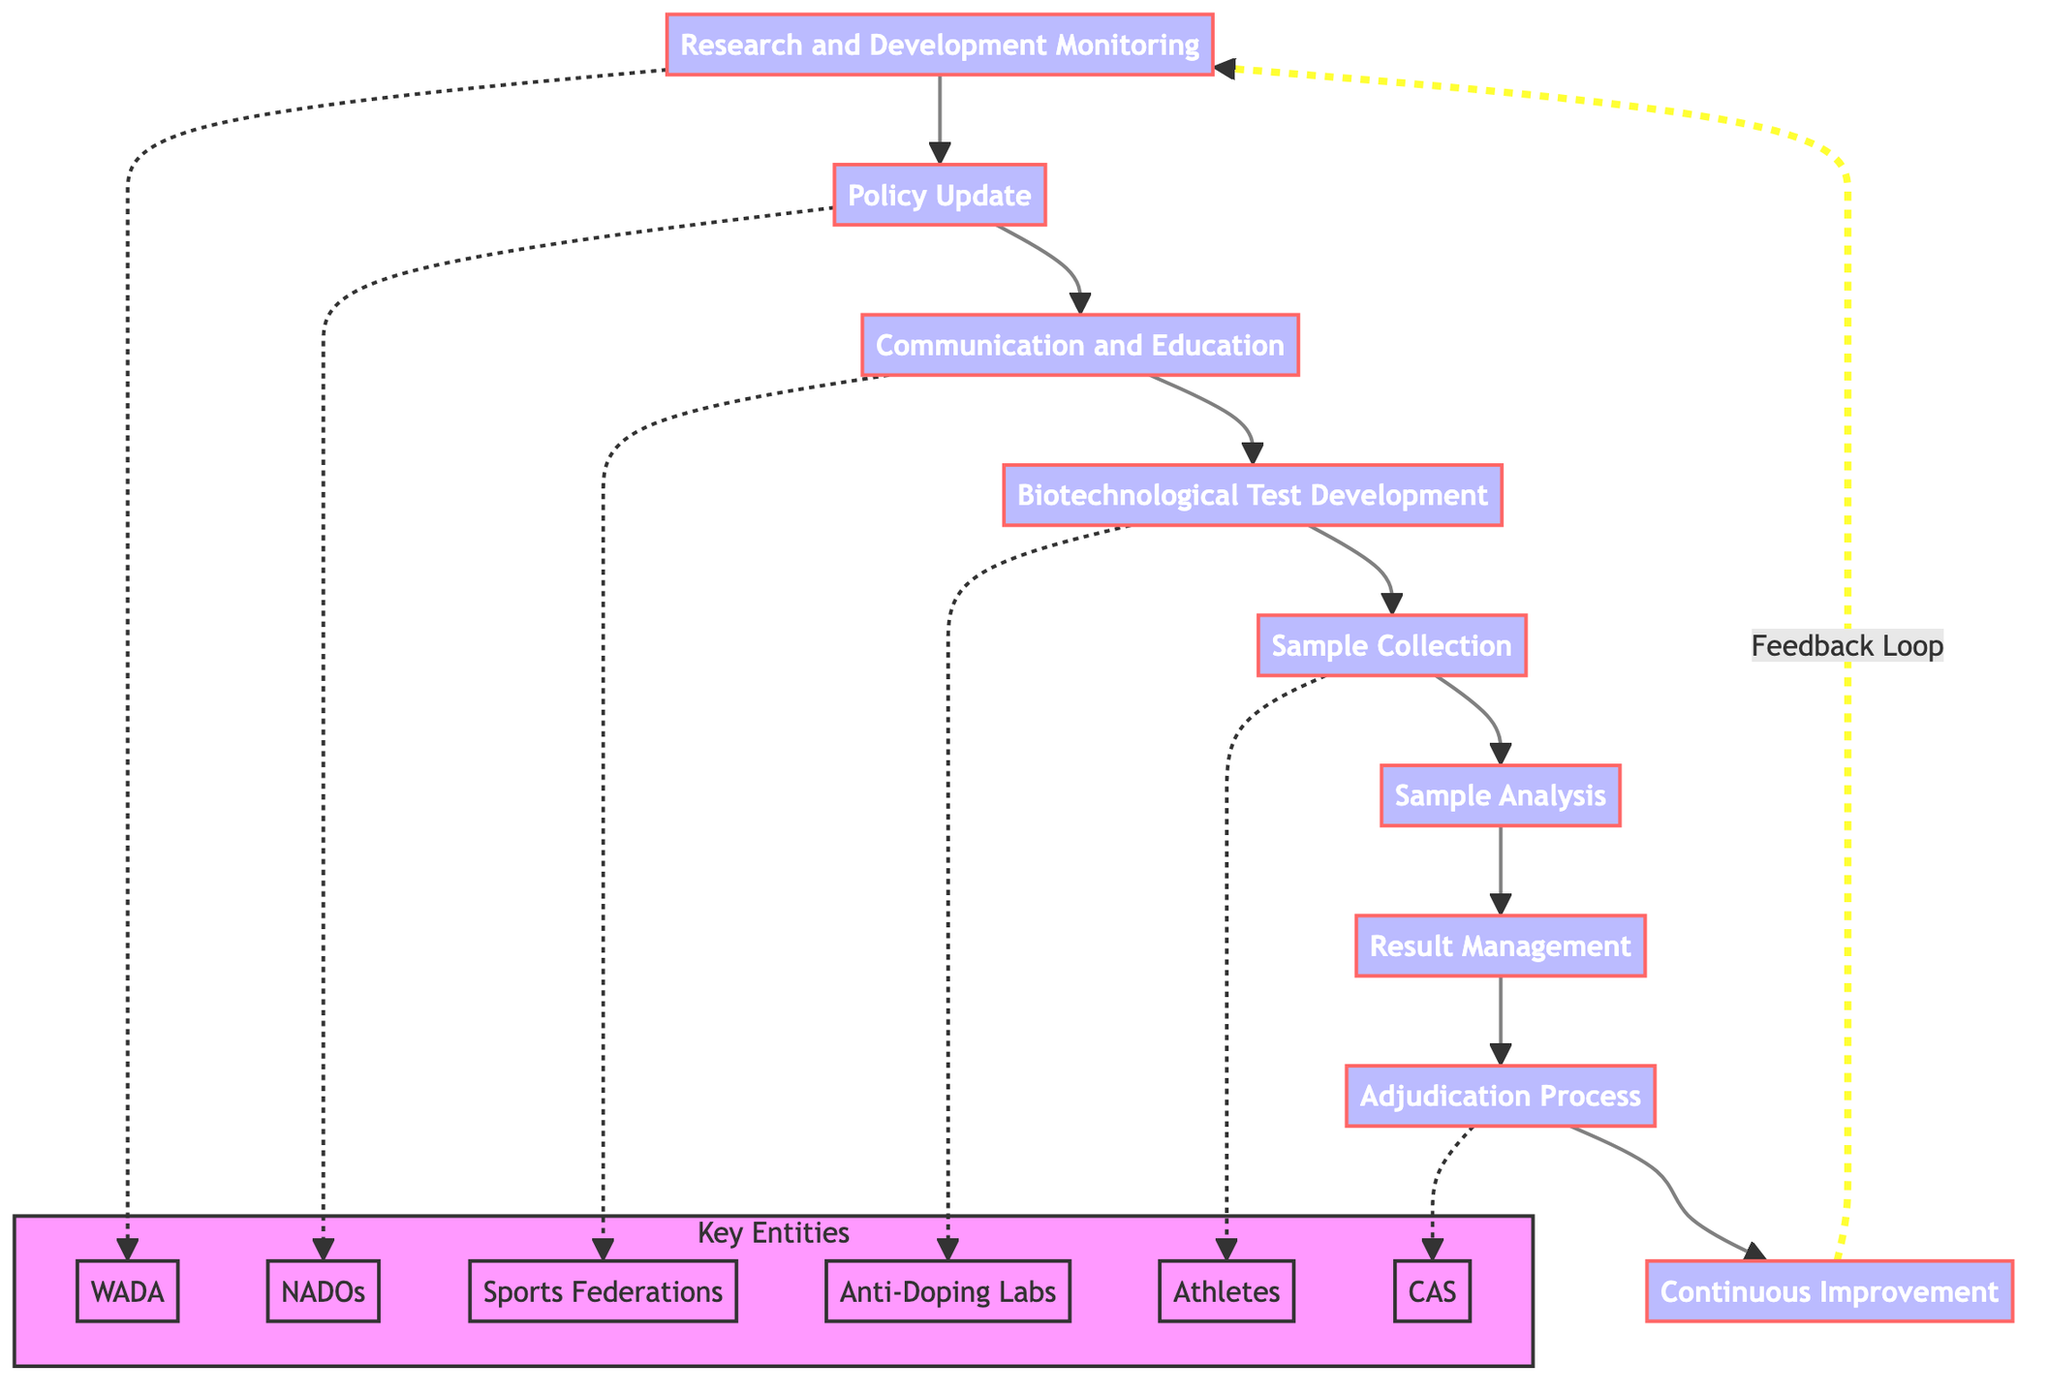What is the first step in the workflow? The first step is labeled "Research and Development Monitoring," which serves as the starting point of the flowchart before moving to the next step.
Answer: Research and Development Monitoring How many total steps are there in the workflow? There are a total of nine steps in the workflow, as counted from the flowchart.
Answer: Nine Which step comes after "Policy Update"? The step that comes directly after "Policy Update" is "Communication and Education," following the flow from one step to the next.
Answer: Communication and Education Which entities are involved in the "Sample Collection" step? The entities listed for the "Sample Collection" step include "Doping Control Officers," "Athletes," and "Official Testing Sites," which help in the process of collecting samples.
Answer: Doping Control Officers, Athletes, Official Testing Sites What is the final step in the workflow? The last step in the workflow is called "Continuous Improvement," indicating that the process loops back for ongoing updates and enhancements.
Answer: Continuous Improvement Which entity is mentioned in both the "Research and Development Monitoring" and "Policy Update" steps? The entity mentioned in both steps is "WADA," highlighting its involvement in both tracking new technologies and updating policies accordingly.
Answer: WADA What is the primary function of "Sample Analysis"? The primary function of "Sample Analysis" is to analyze collected samples using newly developed tests, indicating a step dedicated to evaluating the samples for potential doping.
Answer: Analyze collected samples using newly developed tests How does the workflow utilize feedback? The workflow utilizes feedback through the "Continuous Improvement" step, which loops back to "Research and Development Monitoring" for further enhancements based on earlier steps and feedback.
Answer: Feedback Loop What role do National Anti-Doping Organizations (NADOs) play in the workflow? National Anti-Doping Organizations (NADOs) are involved in both the "Policy Update" and "Adjudication Process" steps, indicating their critical role in policy changes and handling violations.
Answer: Policy Update, Adjudication Process 